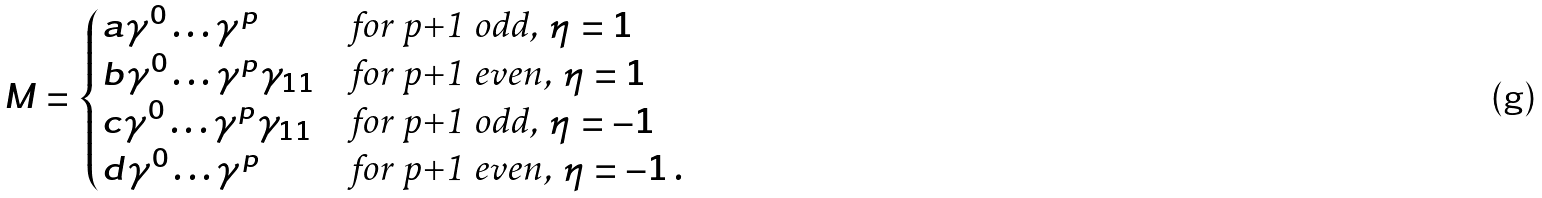Convert formula to latex. <formula><loc_0><loc_0><loc_500><loc_500>M = \begin{cases} a \gamma ^ { 0 } \dots \gamma ^ { p } & \text {for p+1 odd, $\eta=1$} \\ b \gamma ^ { 0 } \dots \gamma ^ { p } \gamma _ { 1 1 } & \text {for p+1 even, $\eta=1$} \\ c \gamma ^ { 0 } \dots \gamma ^ { p } \gamma _ { 1 1 } & \text {for p+1 odd, $\eta=-1$} \\ d \gamma ^ { 0 } \dots \gamma ^ { p } & \text {for p+1 even, $\eta=-1$} \, . \end{cases}</formula> 